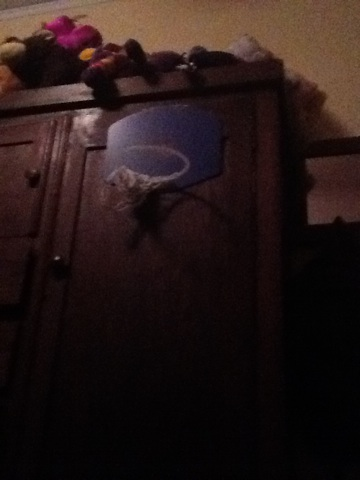What do you think the person who owns this room likes to do in their free time? It looks like the person who owns this room enjoys playing indoor basketball, as evidenced by the basketball hoop mounted on the furniture. Additionally, the stuffed animals suggest they might also enjoy collecting toys or have a fondness for plush items. Their free time might be spent playing games, shooting hoops, or engaging in imaginative play with their stuffed animal collection. If you had to create a story based on this image, what would it be? Once upon a time, there was a young basketball enthusiast named Jamie who loved practicing trick shots with their mini hoop mounted on the wardrobe in their room. Jamie's collection of stuffed animals, which resided on top of the wardrobe, would cheer and applaud after every successful shot. Each evening, Jamie would put on thrilling basketball matches, with the stuffed animals serving as both audience and teammates. One day, Jamie discovered that the stuffed animals had come to life, and together, they formed an unstoppable basketball team. They traveled through magical realms, challenging various mythical creatures to basketball games and spreading joy and sportsmanship wherever they went. 